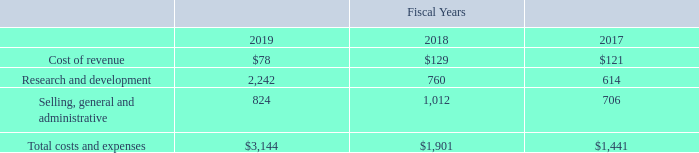Stock-based compensation expense is recognized in the Company’s consolidated statements of operations and includes compensation expense for the stock-based compensation awards granted or modified subsequent to January 1, 2006, based on the grant date fair value estimated in accordance with the provisions of the amended authoritative guidance. The impact on the Company’s results of operations of recording stock-based compensation expense for fiscal years 2019, 2018, and 2017 was as follows (in thousands):
No stock-based compensation was capitalized or included in inventories at the end of 2019, 2018 and 2017.
What are the respective values of the stock-based compensation for the cost of revenue in 2018 and 2019?
Answer scale should be: thousand. $129, $78. What are the respective values of the stock-based compensation for research and development in 2018 and 2019?
Answer scale should be: thousand. 760, 2,242. What are the respective values of the stock-based compensation for selling, general and administrative in 2018 and 2019?
Answer scale should be: thousand. 1,012, 824. What is the total stock-based compensation for the cost of revenue in 2018 and 2019?
Answer scale should be: thousand. ($129 + $78) 
Answer: 207. What is the average stock-based compensation for research and development in 2018 and 2019?
Answer scale should be: thousand. (760 +  2,242)/2 
Answer: 1501. What is the value of the 2018 stock-based compensation for selling, general and administrative as a percentage of the 2019 stock-based compensation for selling, general and administrative?
Answer scale should be: percent. 1,012/ 824 
Answer: 122.82. 